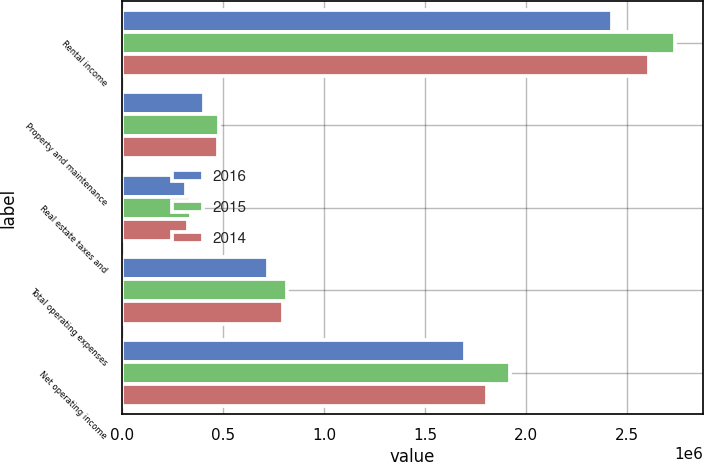Convert chart. <chart><loc_0><loc_0><loc_500><loc_500><stacked_bar_chart><ecel><fcel>Rental income<fcel>Property and maintenance<fcel>Real estate taxes and<fcel>Total operating expenses<fcel>Net operating income<nl><fcel>2016<fcel>2.42223e+06<fcel>406823<fcel>317387<fcel>724210<fcel>1.69802e+06<nl><fcel>2015<fcel>2.73658e+06<fcel>479160<fcel>339802<fcel>818962<fcel>1.91762e+06<nl><fcel>2014<fcel>2.60531e+06<fcel>473098<fcel>325401<fcel>798499<fcel>1.80681e+06<nl></chart> 